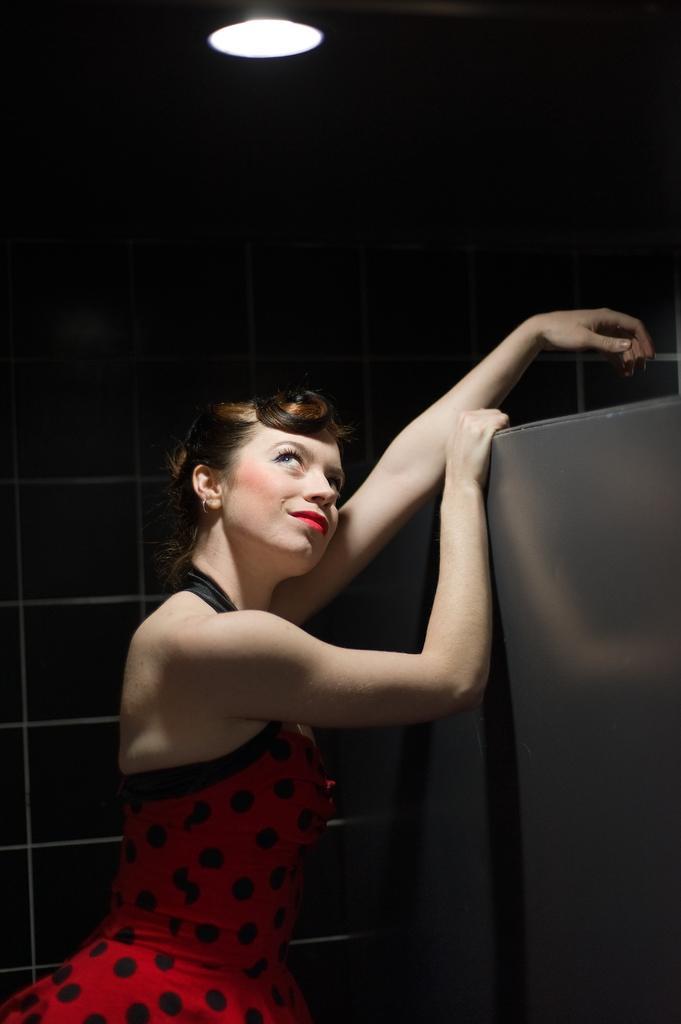Can you describe this image briefly? On the left there is a woman in red dress. On the right there is an iron object. In the background it is well. At the top it is light. 